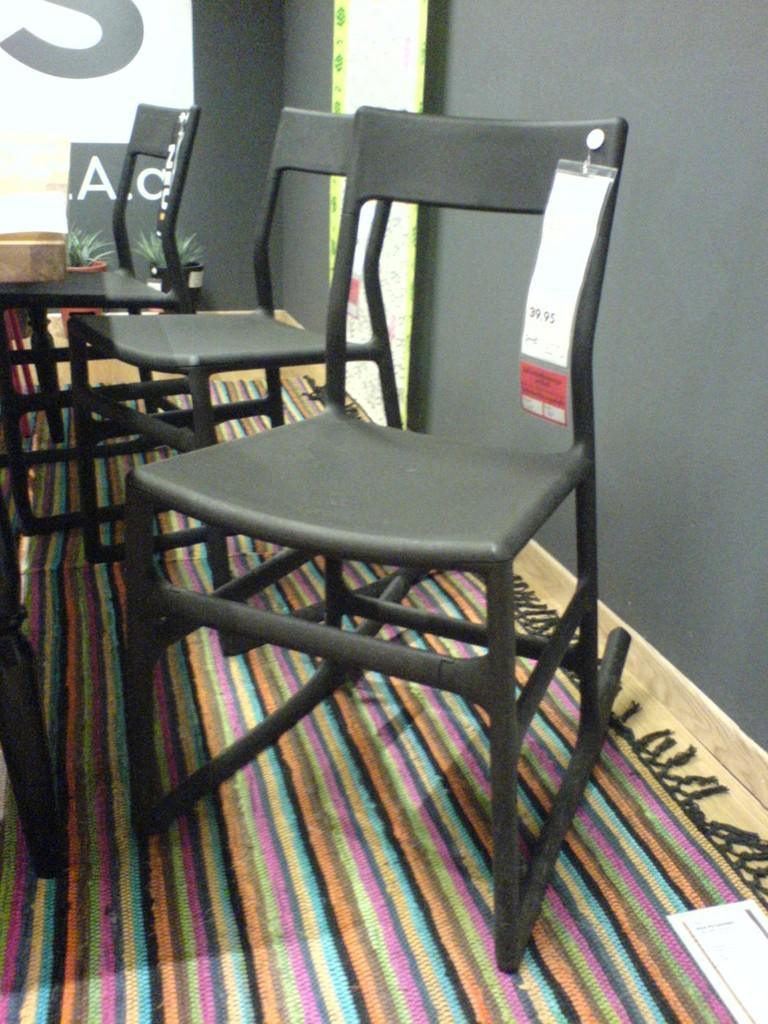How many chairs are present in the image? There are three chairs in the image. Where are the chairs located? The chairs are kept on the floor. What else can be seen in the image besides the chairs? There is a flower pot in the image. What is visible in the background of the image? There is a wall visible in the image. What flavor of rose can be smelled in the image? There is no rose present in the image, so it is not possible to determine its flavor. 